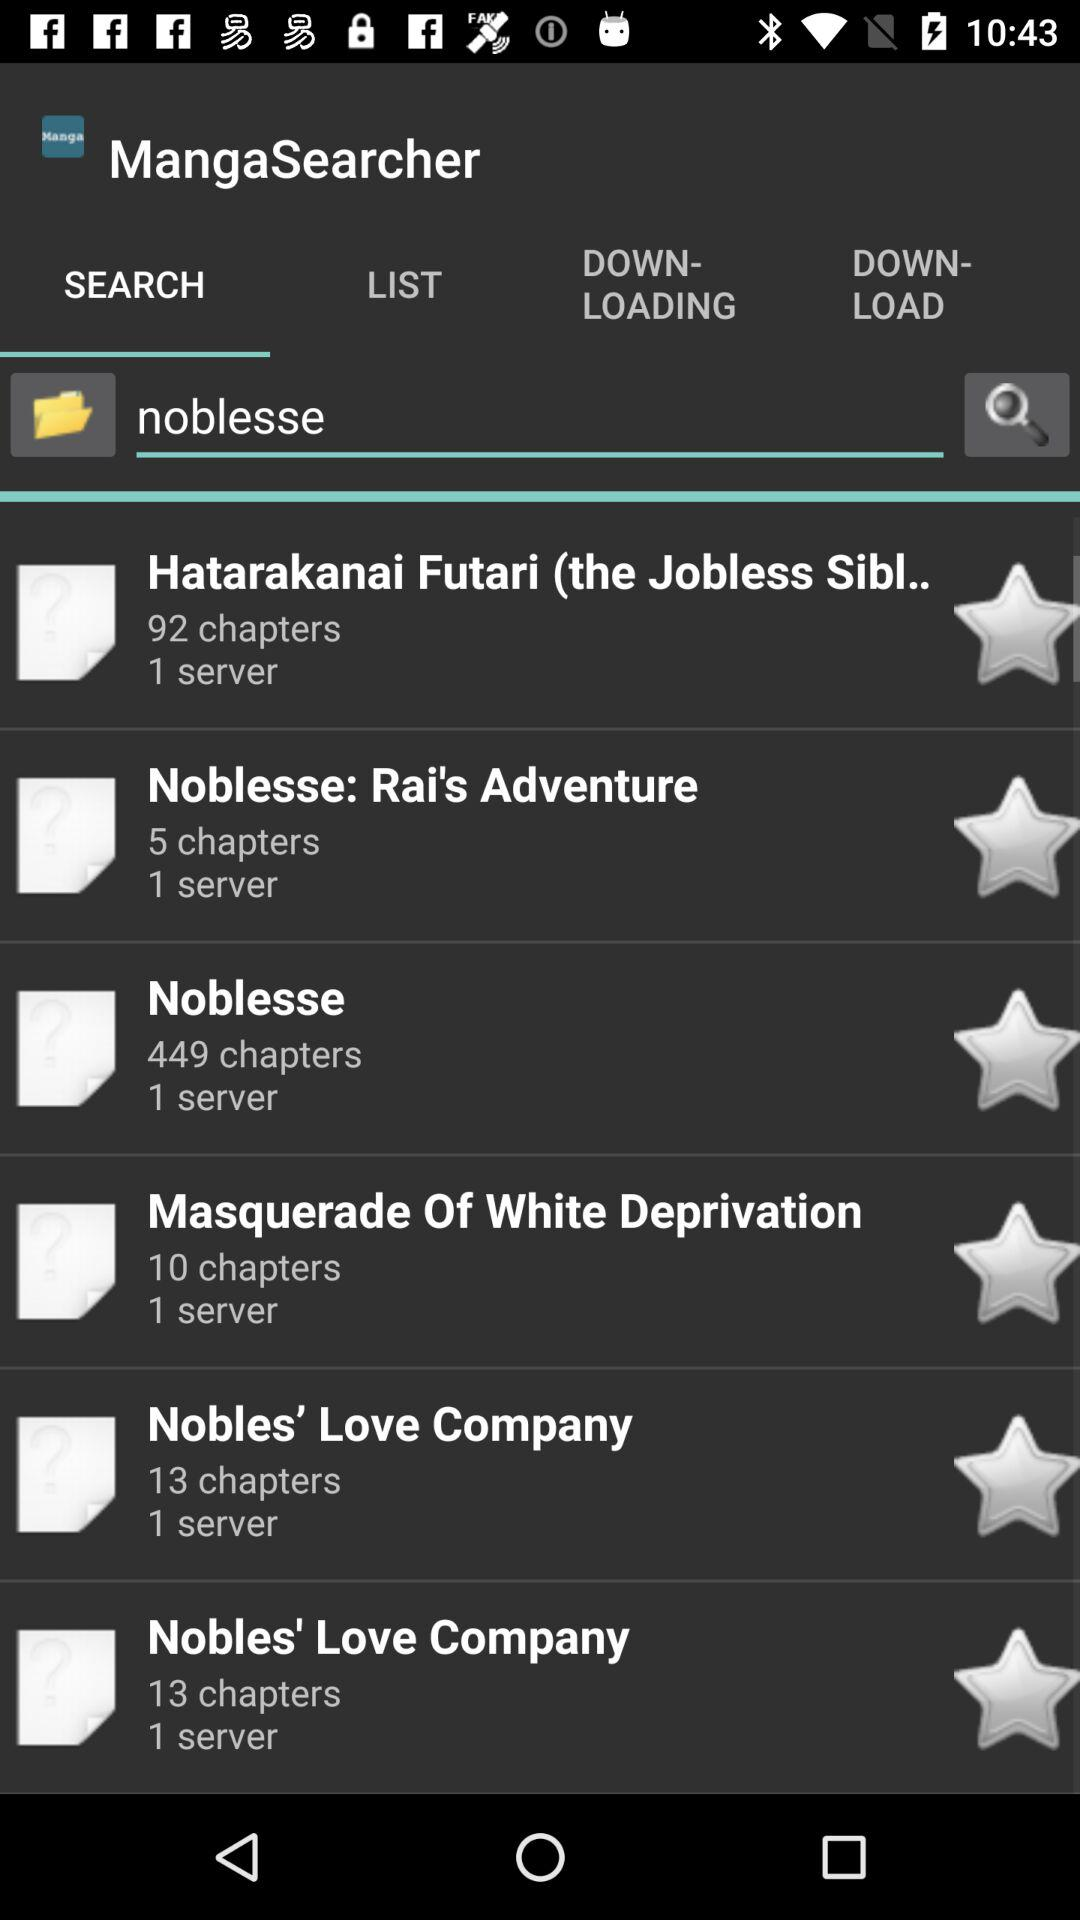Which manga has 45 chapters?
When the provided information is insufficient, respond with <no answer>. <no answer> 